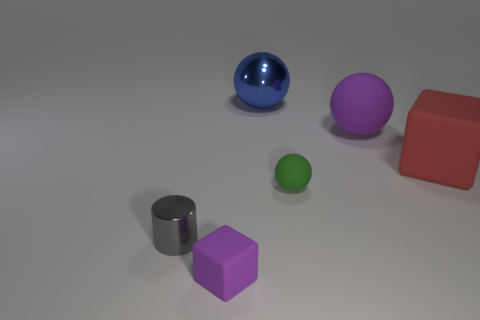How many things are either purple matte things behind the tiny metal thing or big brown metallic cylinders?
Your answer should be compact. 1. What is the color of the ball that is made of the same material as the cylinder?
Your response must be concise. Blue. Is there a blue thing that has the same size as the purple sphere?
Offer a very short reply. Yes. There is a large sphere on the left side of the green thing; does it have the same color as the tiny matte cube?
Your response must be concise. No. What is the color of the object that is both left of the green rubber thing and behind the tiny green rubber sphere?
Your answer should be very brief. Blue. There is a gray metallic thing that is the same size as the green ball; what shape is it?
Offer a very short reply. Cylinder. Is there another object of the same shape as the big shiny object?
Provide a short and direct response. Yes. Is the size of the metallic object behind the green object the same as the red rubber block?
Your answer should be very brief. Yes. There is a matte thing that is to the left of the large rubber cube and behind the green matte object; what is its size?
Offer a very short reply. Large. What number of other objects are the same material as the tiny green thing?
Keep it short and to the point. 3. 